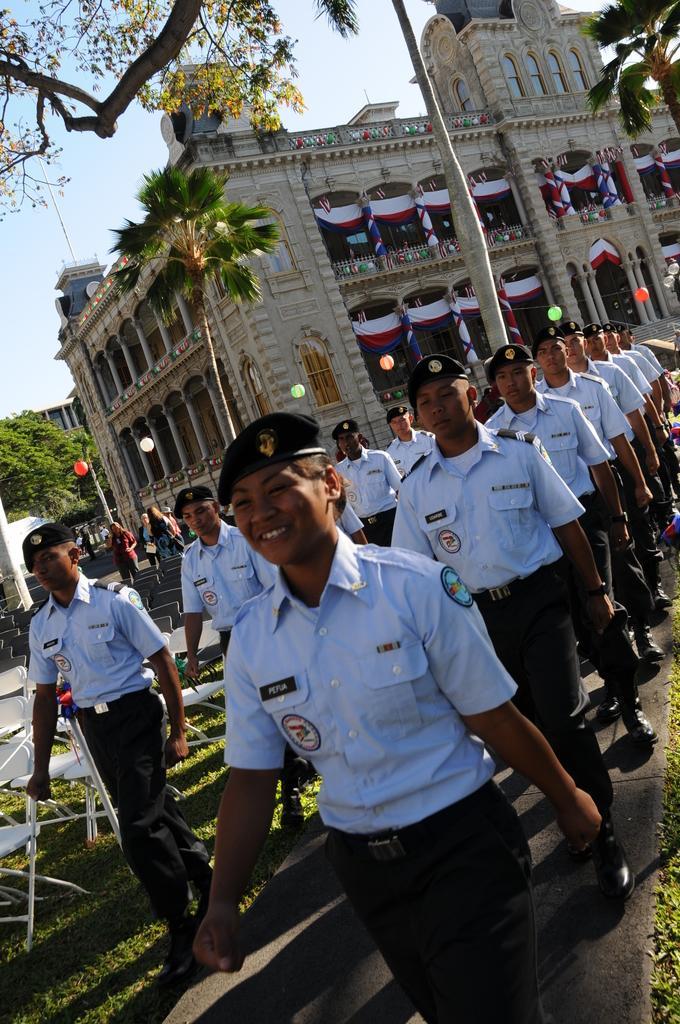Could you give a brief overview of what you see in this image? In this image I can see a path in the front and on it I can see number of people are walking. I can see all of them are wearing uniforms, shoes and caps. On the left side of the image I can see a grass ground and on it I can few white chairs. In the background I can see few buildings, few trees, number of flags, few balloons and the sky. I can also see few more people in the background. 